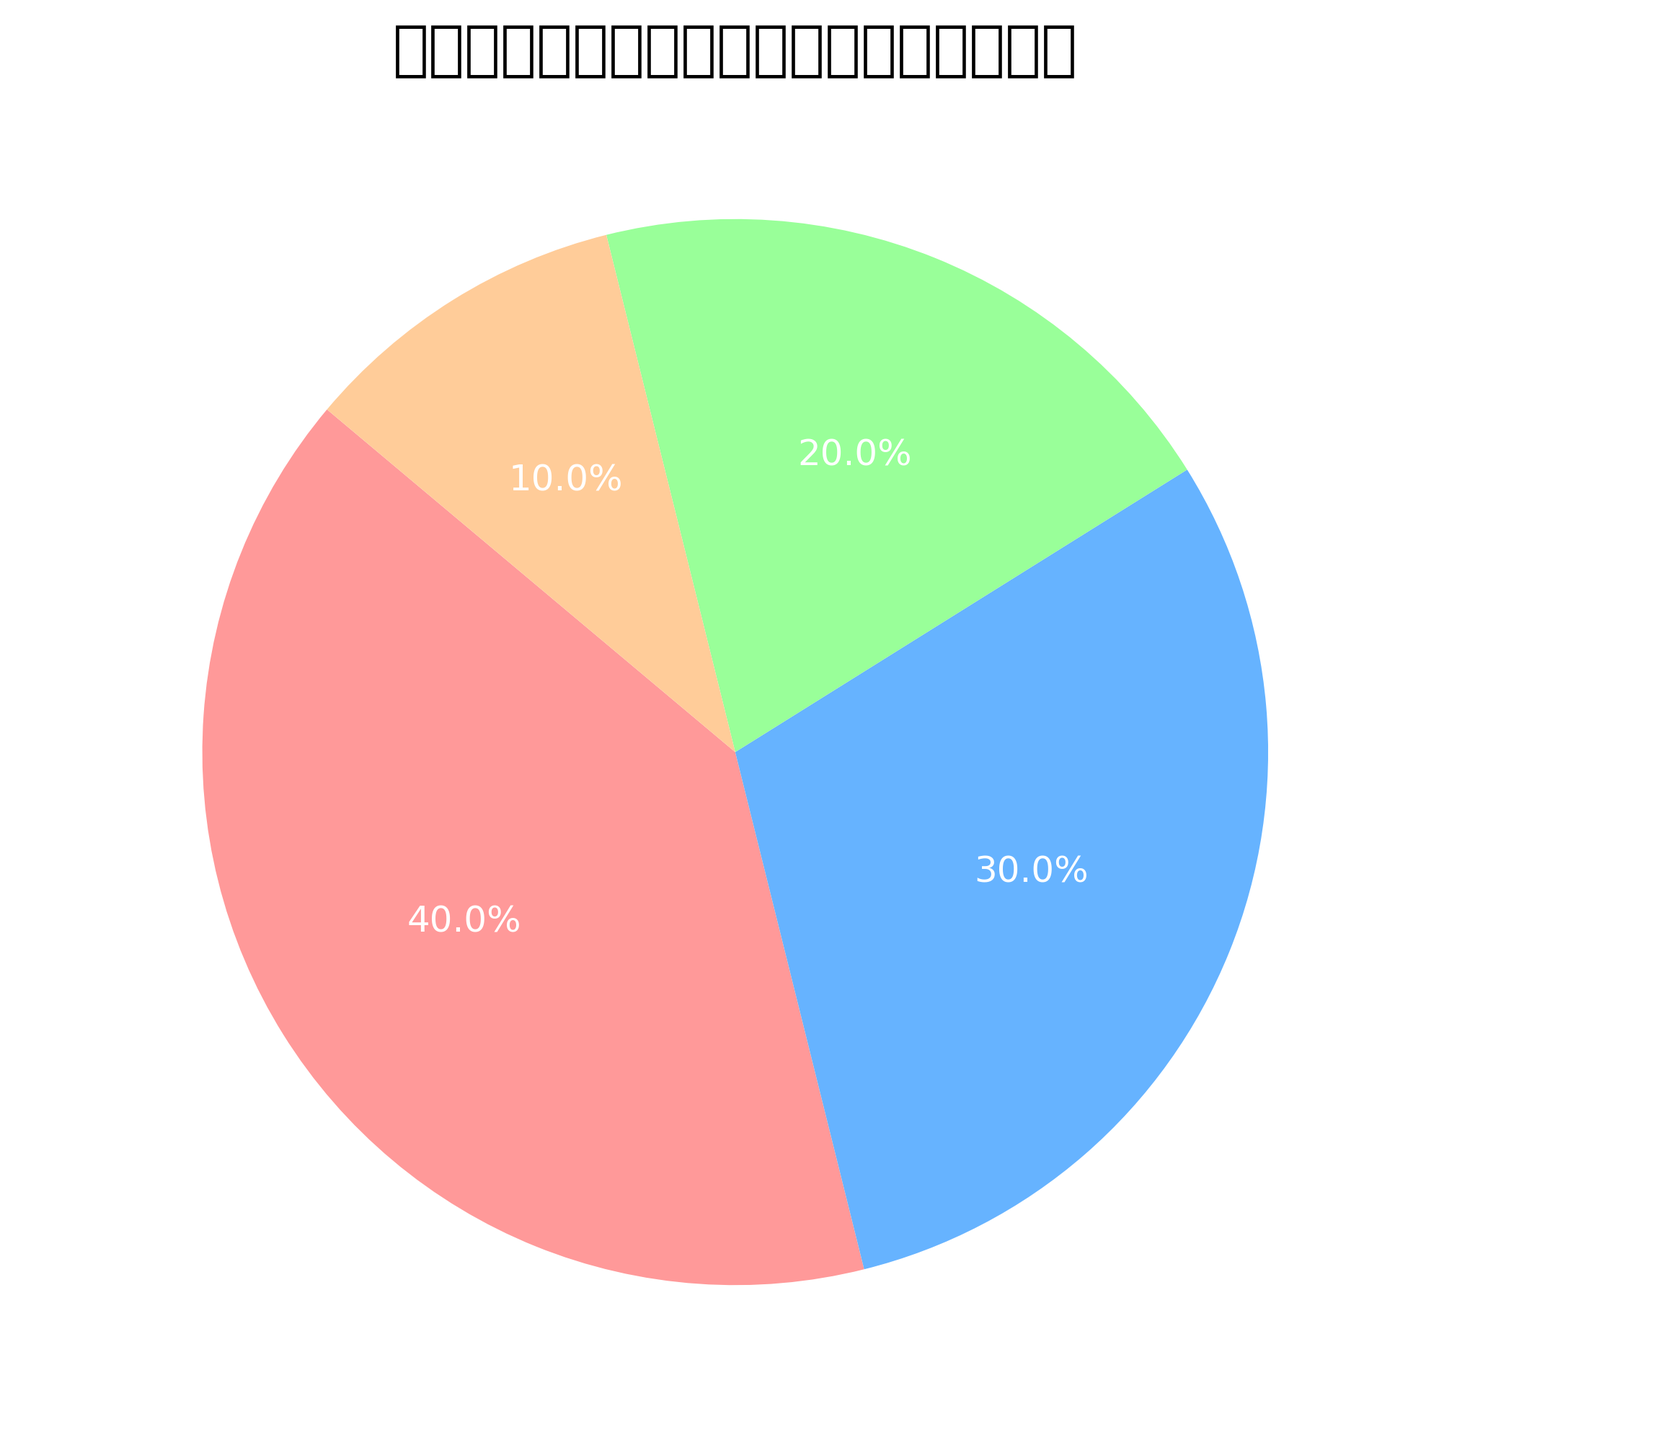What percentage of Japan's geology is influenced by the Pacific Plate? The label for the Pacific Plate indicates its share is 40%.
Answer: 40% What is the combined influence of the Philippine Sea Plate and the Eurasian Plate on Japan's geology? The Philippine Sea Plate's influence is 30%, and the Eurasian Plate's influence is 20%. Adding these together, 30% + 20% = 50%.
Answer: 50% Which plate has the least influence on Japan's geology? According to the pie chart, the North American Plate has the smallest share, which is 10%.
Answer: North American Plate Is the influence of the Pacific Plate greater than the combined influence of the Eurasian Plate and the North American Plate? The Pacific Plate has 40% influence. The Eurasian Plate has 20% and the North American Plate has 10%, making their combined influence 20% + 10% = 30%. Since 40% > 30%, the Pacific Plate has a greater influence.
Answer: Yes What is the difference in influence between the Philippine Sea Plate and the North American Plate? The Philippine Sea Plate has a 30% influence, while the North American Plate has a 10% influence. The difference is 30% - 10% = 20%.
Answer: 20% Which plate influences Japan’s geology more: the Eurasian Plate or the North American Plate? The Eurasian Plate has a 20% influence, whereas the North American Plate has a 10% influence. Since 20% > 10%, the Eurasian Plate has more influence.
Answer: Eurasian Plate What color represents the Eurasian Plate in the pie chart? The pie chart has assigned the color green (represented by the hex code #99ff99) to the Eurasian Plate.
Answer: Green What is the combined influence of the Pacific Plate and the North American Plate on Japan's geology? The Pacific Plate influences Japan's geology by 40%, and the North American Plate influences by 10%. Adding these together, 40% + 10% = 50%.
Answer: 50% By how much does the influence of the Pacific Plate exceed the influence of the Philippine Sea Plate? The influence of the Pacific Plate is 40%, and the influence of the Philippine Sea Plate is 30%. The difference is 40% - 30% = 10%.
Answer: 10% Is the combined influence of the Eurasian Plate and the North American Plate greater than that of the Philippine Sea Plate? The Eurasian Plate has a 20% influence and the North American Plate has a 10% influence, making their combined influence 20% + 10% = 30%. The Philippine Sea Plate also has a 30% influence. Since 30% is not greater than 30%, the combined influence is not greater.
Answer: No 